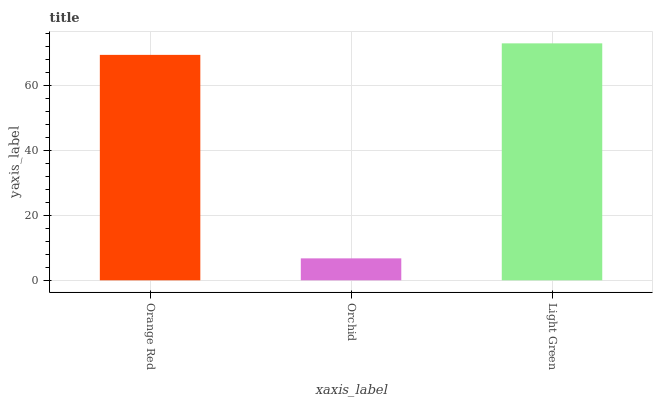Is Orchid the minimum?
Answer yes or no. Yes. Is Light Green the maximum?
Answer yes or no. Yes. Is Light Green the minimum?
Answer yes or no. No. Is Orchid the maximum?
Answer yes or no. No. Is Light Green greater than Orchid?
Answer yes or no. Yes. Is Orchid less than Light Green?
Answer yes or no. Yes. Is Orchid greater than Light Green?
Answer yes or no. No. Is Light Green less than Orchid?
Answer yes or no. No. Is Orange Red the high median?
Answer yes or no. Yes. Is Orange Red the low median?
Answer yes or no. Yes. Is Orchid the high median?
Answer yes or no. No. Is Light Green the low median?
Answer yes or no. No. 